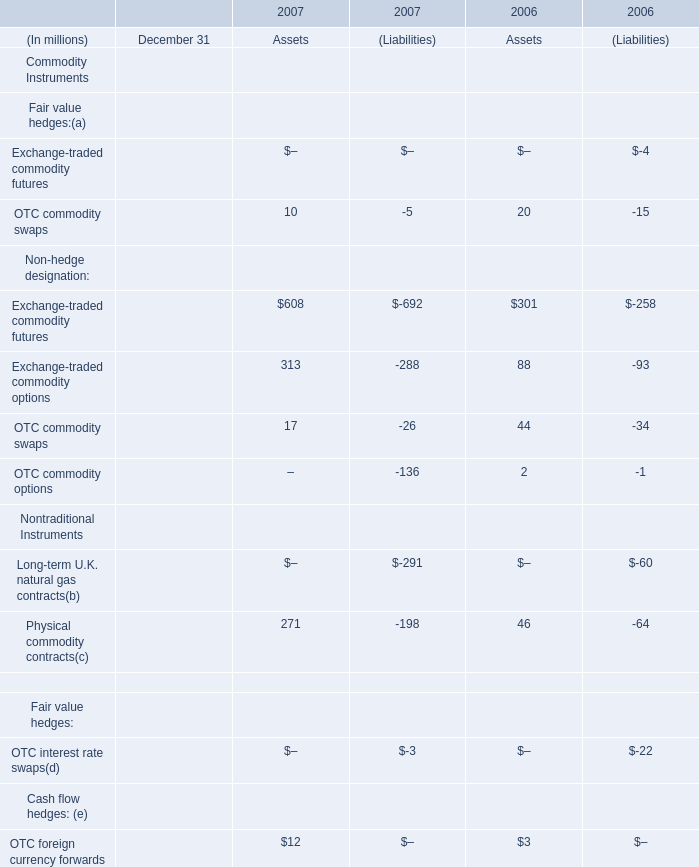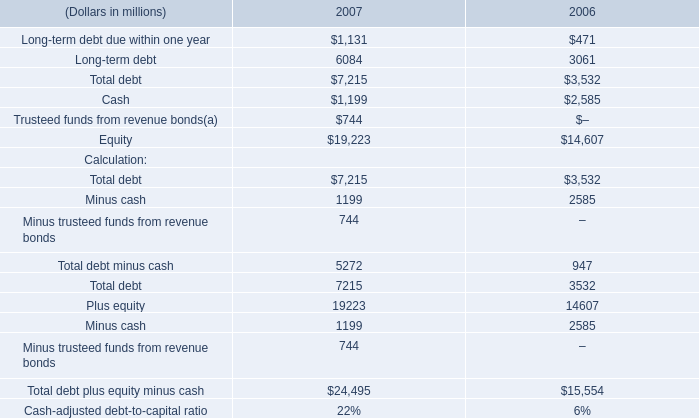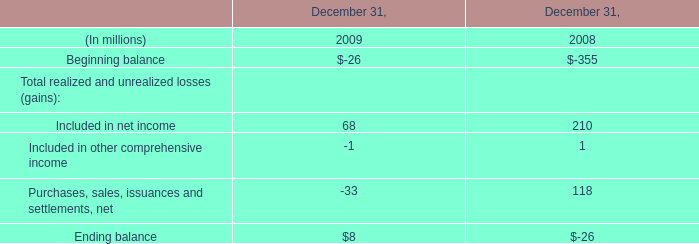in millions , what would 2007 total debt increase to if the company fully draws its available revolver? 
Computations: ((3.0 * 1000) + 7215)
Answer: 10215.0. 